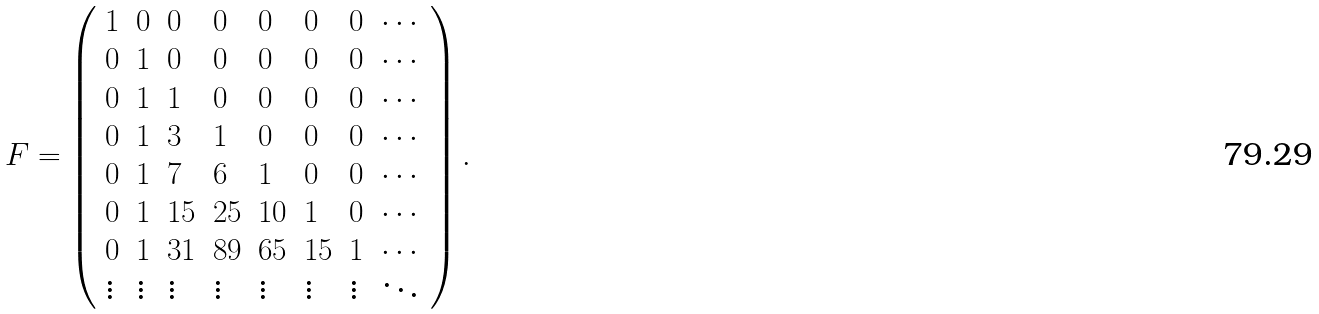<formula> <loc_0><loc_0><loc_500><loc_500>F = \left ( \begin{array} { l l l l l l l l } 1 & 0 & 0 & 0 & 0 & 0 & 0 & \cdots \\ 0 & 1 & 0 & 0 & 0 & 0 & 0 & \cdots \\ 0 & 1 & 1 & 0 & 0 & 0 & 0 & \cdots \\ 0 & 1 & 3 & 1 & 0 & 0 & 0 & \cdots \\ 0 & 1 & 7 & 6 & 1 & 0 & 0 & \cdots \\ 0 & 1 & 1 5 & 2 5 & 1 0 & 1 & 0 & \cdots \\ 0 & 1 & 3 1 & 8 9 & 6 5 & 1 5 & 1 & \cdots \\ \vdots & \vdots & \vdots & \vdots & \vdots & \vdots & \vdots & \ddots \end{array} \right ) .</formula> 